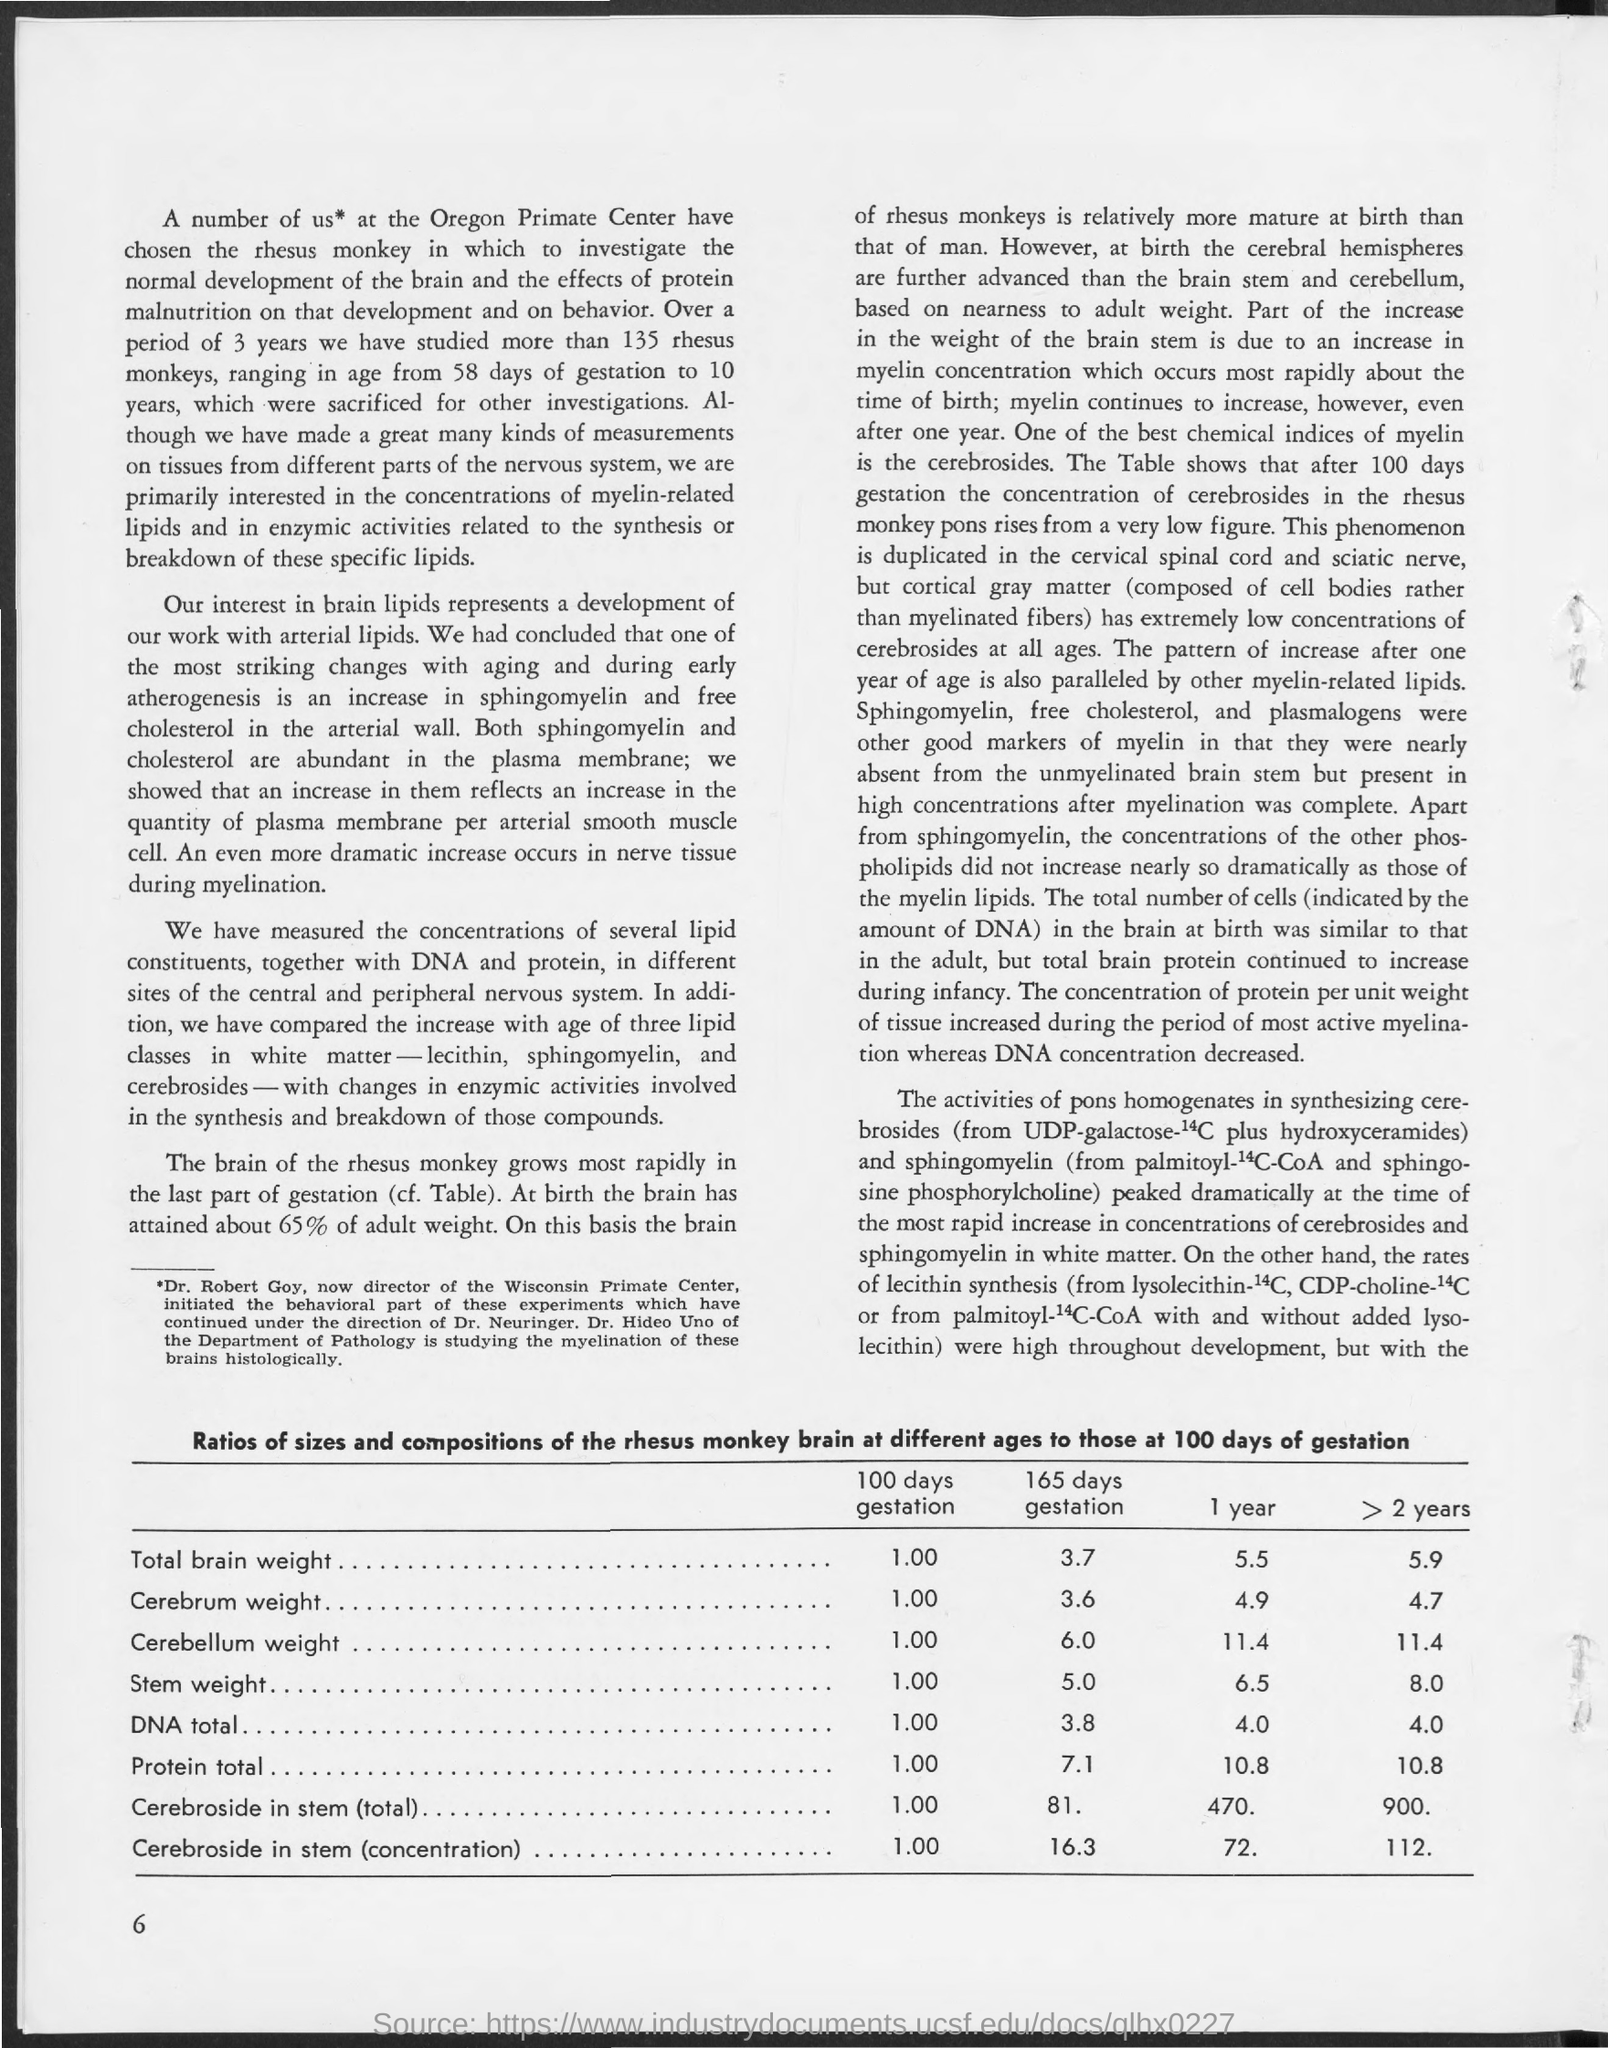Highlight a few significant elements in this photo. The total brain weight for a 1-year gestation is approximately 5.5. The total weight of the brain for a 165-day gestation period is 3.7. The estimated cerebrum weight for a 1-year gestation is 4.9 grams. The study lasted for a period of 3.. The total brain weight for infants who have been gestated for more than two years is 5.9. 